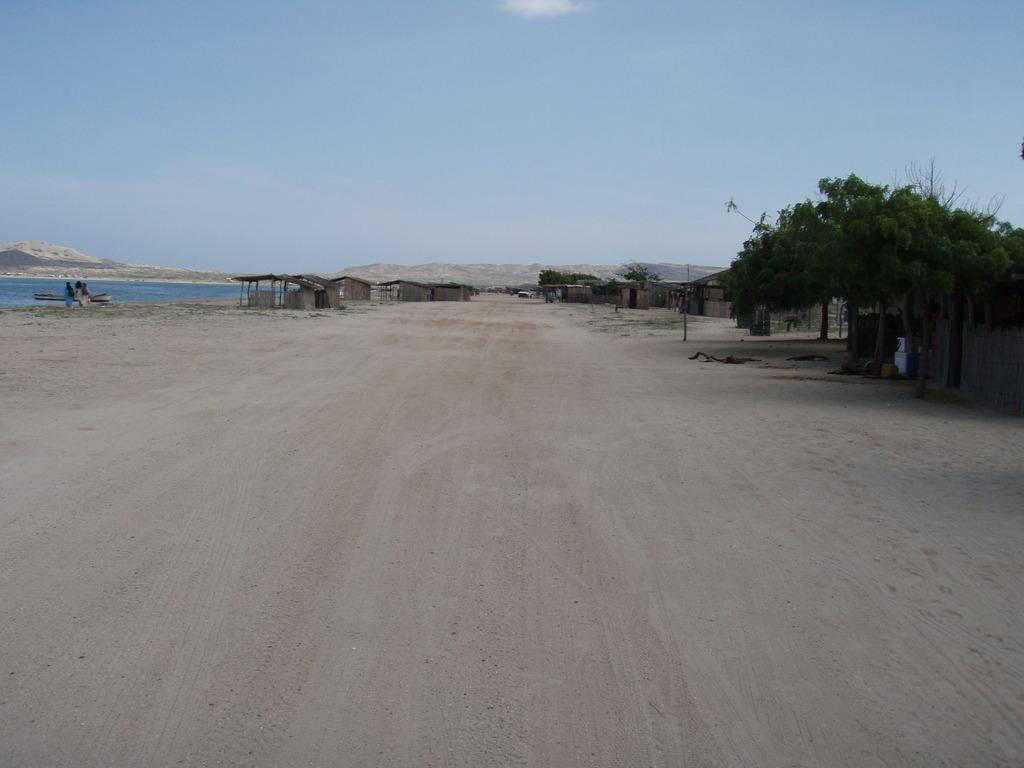In one or two sentences, can you explain what this image depicts? Far we can see houses, trees, mountains and water. Sky is in blue color. 